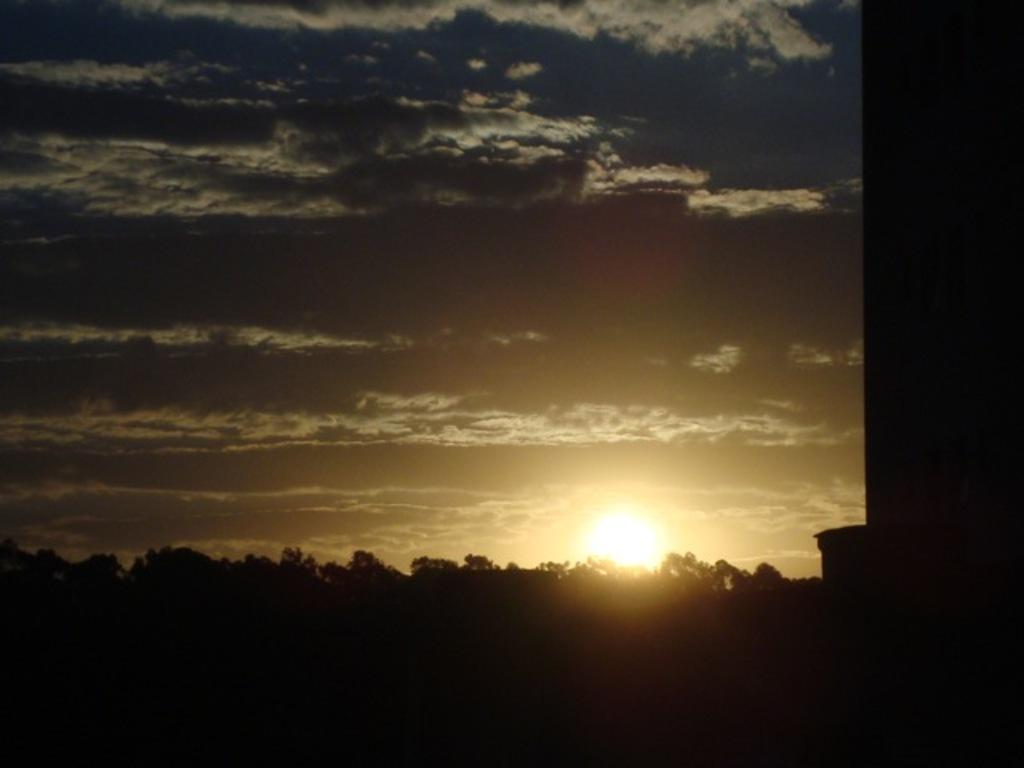What type of vegetation can be seen in the image? There are trees in the image. What celestial body is visible in the image? The sun is visible in the image. What else can be seen in the sky besides the sun? The sky is visible in the image, but no other celestial bodies or objects are mentioned. How many parcels are being delivered by the trees in the image? There are no parcels mentioned or visible in the image; it only features trees and the sun. What type of treatment is being administered to the sky in the image? There is no treatment being administered to the sky in the image; it is simply visible. 